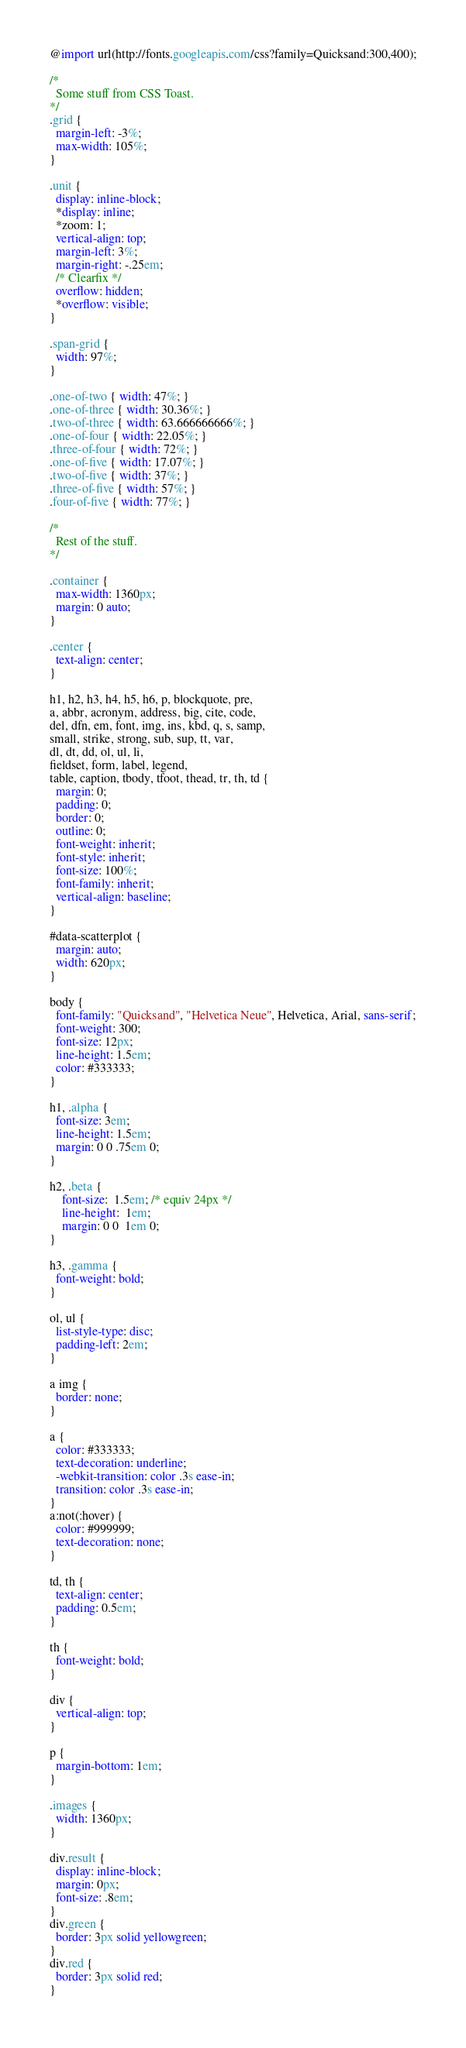Convert code to text. <code><loc_0><loc_0><loc_500><loc_500><_CSS_>@import url(http://fonts.googleapis.com/css?family=Quicksand:300,400);

/*
  Some stuff from CSS Toast.
*/
.grid {
  margin-left: -3%;
  max-width: 105%;
}

.unit {
  display: inline-block;
  *display: inline;
  *zoom: 1;
  vertical-align: top;
  margin-left: 3%;
  margin-right: -.25em;
  /* Clearfix */
  overflow: hidden;
  *overflow: visible;
}

.span-grid {
  width: 97%;
}

.one-of-two { width: 47%; }
.one-of-three { width: 30.36%; }
.two-of-three { width: 63.666666666%; }
.one-of-four { width: 22.05%; }
.three-of-four { width: 72%; }
.one-of-five { width: 17.07%; }
.two-of-five { width: 37%; }
.three-of-five { width: 57%; }
.four-of-five { width: 77%; }

/*
  Rest of the stuff.
*/

.container {
  max-width: 1360px;
  margin: 0 auto;
}

.center {
  text-align: center;
}

h1, h2, h3, h4, h5, h6, p, blockquote, pre,
a, abbr, acronym, address, big, cite, code,
del, dfn, em, font, img, ins, kbd, q, s, samp,
small, strike, strong, sub, sup, tt, var,
dl, dt, dd, ol, ul, li,
fieldset, form, label, legend,
table, caption, tbody, tfoot, thead, tr, th, td {
  margin: 0;
  padding: 0;
  border: 0;
  outline: 0;
  font-weight: inherit;
  font-style: inherit;
  font-size: 100%;
  font-family: inherit;
  vertical-align: baseline;
}

#data-scatterplot {
  margin: auto;
  width: 620px;
}

body {
  font-family: "Quicksand", "Helvetica Neue", Helvetica, Arial, sans-serif;
  font-weight: 300;
  font-size: 12px;
  line-height: 1.5em;
  color: #333333;
}

h1, .alpha {
  font-size: 3em;
  line-height: 1.5em;
  margin: 0 0 .75em 0;
}

h2, .beta {
    font-size:  1.5em; /* equiv 24px */
    line-height:  1em;
    margin: 0 0  1em 0;
}

h3, .gamma {
  font-weight: bold;
}

ol, ul {
  list-style-type: disc;
  padding-left: 2em;
}

a img {
  border: none;
}

a {
  color: #333333;
  text-decoration: underline;
  -webkit-transition: color .3s ease-in;
  transition: color .3s ease-in;
}
a:not(:hover) {
  color: #999999;
  text-decoration: none;
}

td, th {
  text-align: center;
  padding: 0.5em;
}

th {
  font-weight: bold;
}

div {
  vertical-align: top;
}

p {
  margin-bottom: 1em;
}

.images {
  width: 1360px;
}

div.result {
  display: inline-block;
  margin: 0px;
  font-size: .8em;
}
div.green {
  border: 3px solid yellowgreen;
}
div.red {
  border: 3px solid red;
}
</code> 